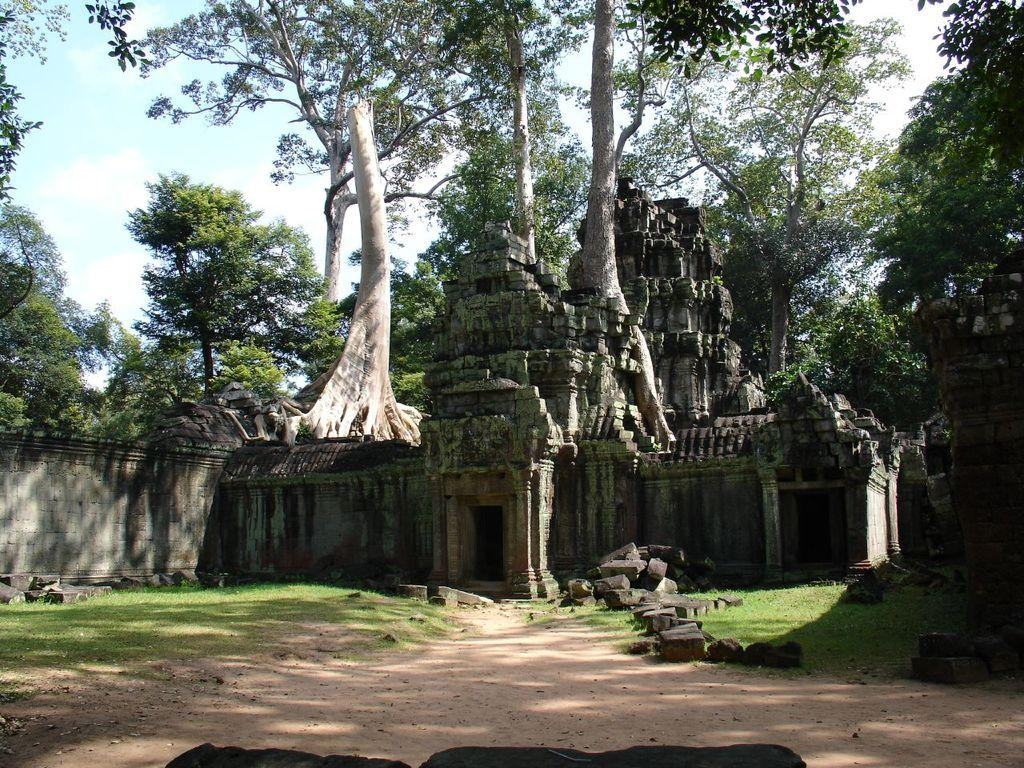What type of building is in the image? There is a temple in the image. What is at the bottom of the image? There is grass and rocks at the bottom of the image. What can be seen in the background of the image? There are trees in the background of the image. What is visible at the top of the image? The sky is visible at the top of the image. Where is the fire hydrant located in the image? There is no fire hydrant present in the image. What type of clock is hanging on the temple in the image? There is no clock visible in the image; it only features a temple, grass, rocks, trees, and the sky. 